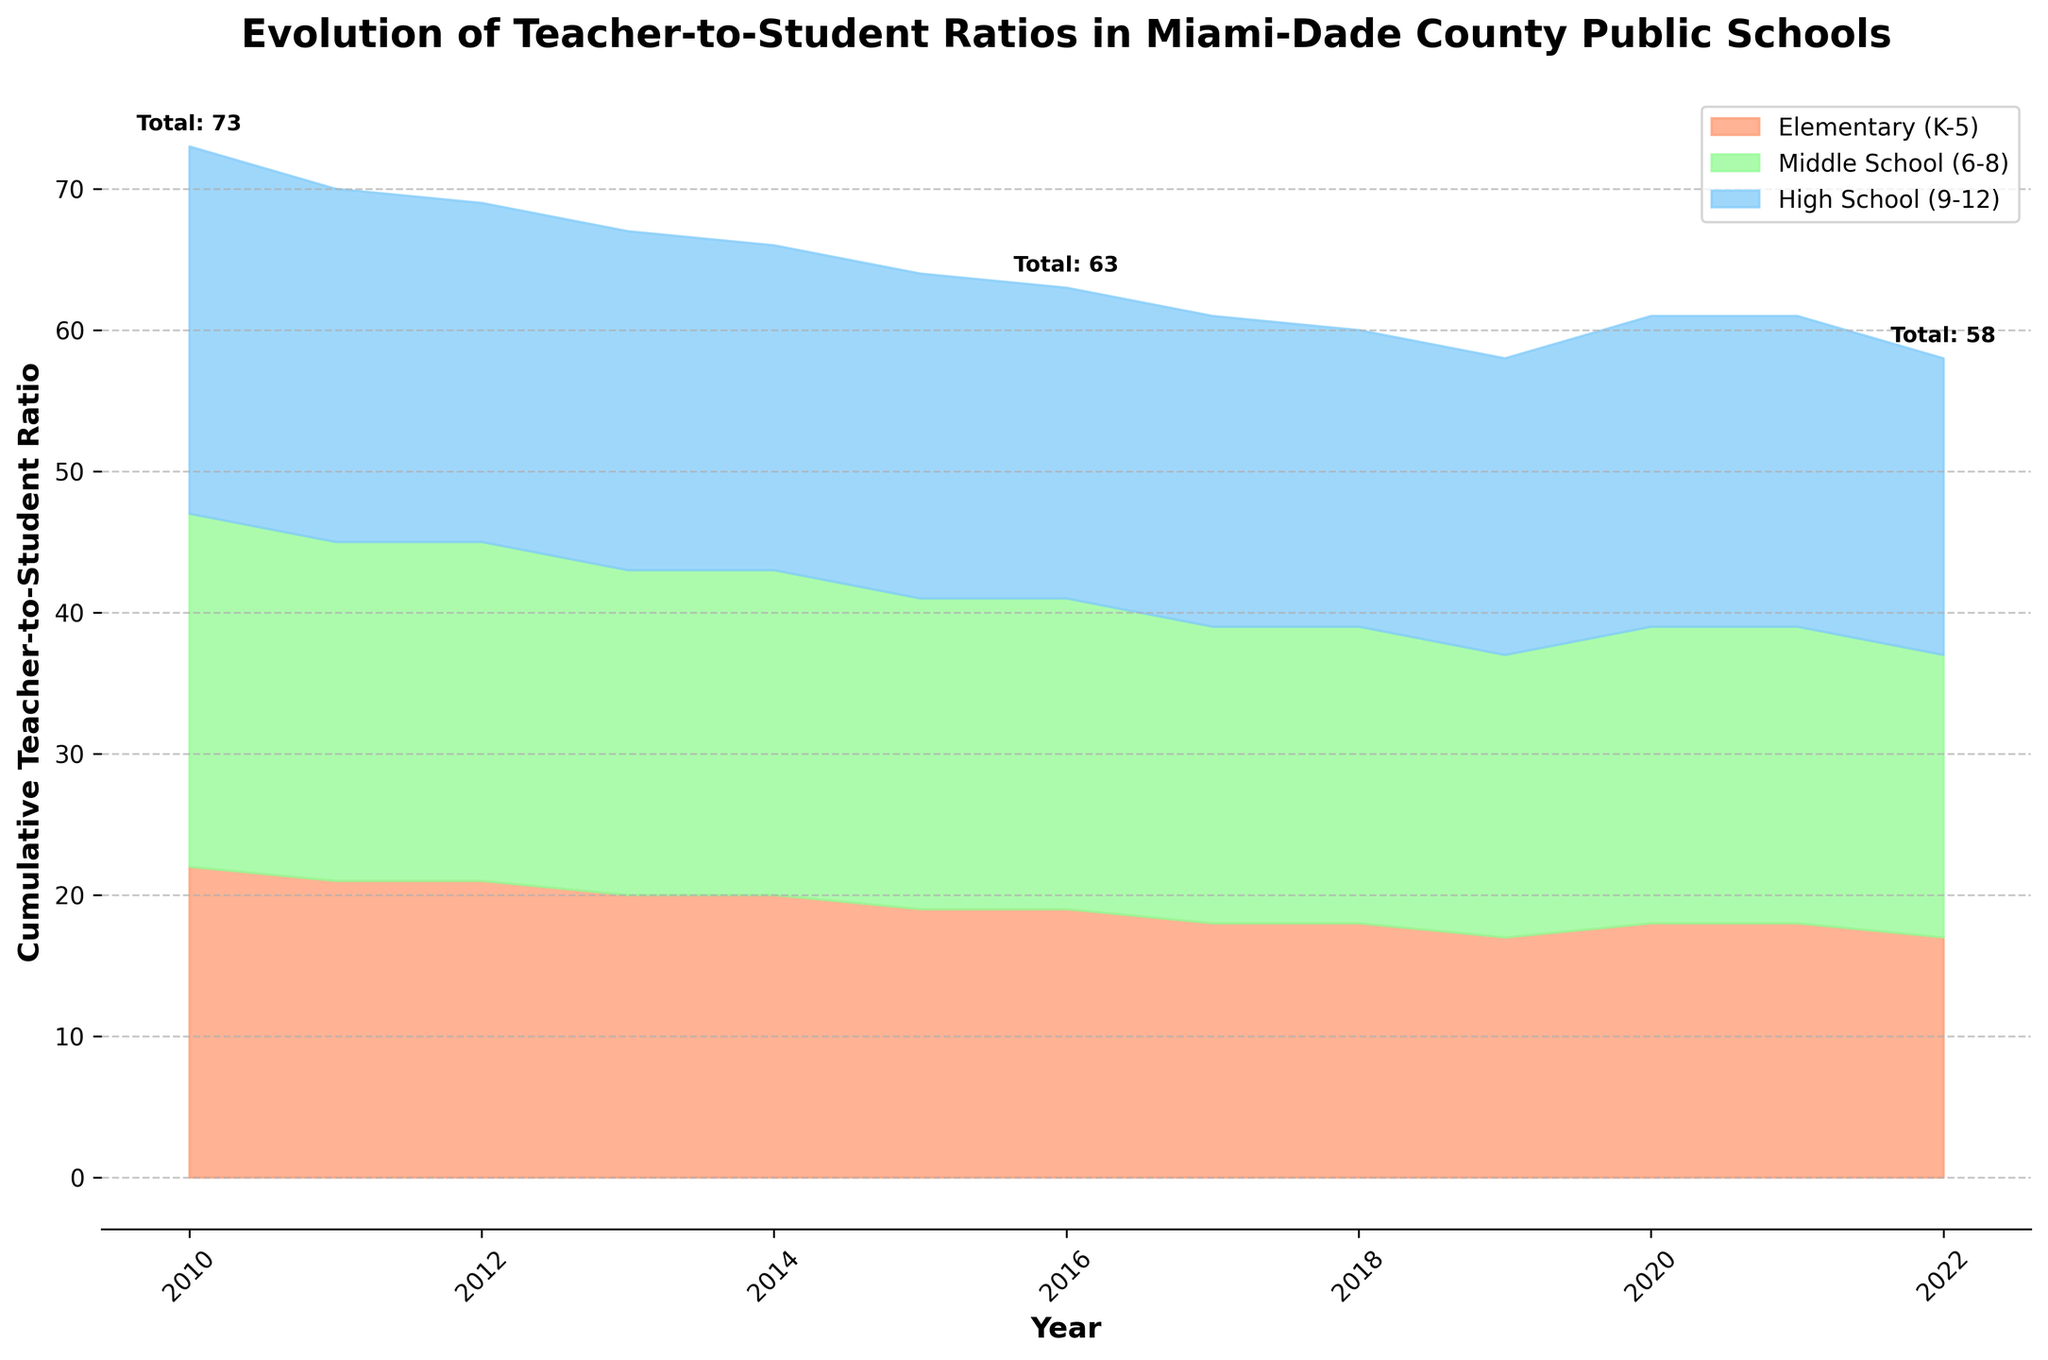What is the title of the figure? The title is usually displayed at the top of the figure. Here, it reads "Evolution of Teacher-to-Student Ratios in Miami-Dade County Public Schools."
Answer: Evolution of Teacher-to-Student Ratios in Miami-Dade County Public Schools In which year did the elementary (K-5) teacher-to-student ratio first reach 1:18? The stream graph shows the progression over time for different grade levels. By observing the area corresponding to elementary (K-5), it first reaches 1:18 in 2018.
Answer: 2018 What was the total cumulative teacher-to-student ratio for all grade levels in 2010? The graph annotates the total cumulative teacher-to-student ratio at specific years. For 2010, the annotation shows that it was 73.
Answer: 73 Which grade level had consistently the highest teacher-to-student ratio throughout most of the years? Observing the graph’s color-coded areas for each grade level, the high school (9-12) consistently occupies the largest vertical space, indicating the highest teacher-to-student ratio.
Answer: High School (9-12) How did the teacher-to-student ratio for middle school (6-8) change from 2015 to 2022? By comparing the height of the middle school area (green) at these two points, we see the ratio decreased from 1:22 in 2015 to 1:20 in 2022.
Answer: Decreased What were the teacher-to-student ratios for high school (9-12) in 2013 and 2019, and what is the difference between them? From the stream graph, the ratio for high school in 2013 is 1:24 and in 2019 is 1:21. The difference is 24 - 21 = 3.
Answer: 3 Which grade level saw the largest improvement (decrease) in teacher-to-student ratio between 2010 and 2022? By observing the overall visual reduction in each area, elementary (K-5) experienced the largest improvement, decreasing from 1:22 in 2010 to 1:17 in 2022.
Answer: Elementary (K-5) What was the trend for elementary (K-5) teacher-to-student ratios from 2016 to 2020? Checking the relevant portion of the graph, elementary (K-5) ratios remained constant at 1:19 from 2016 to 2017, then decreased to 1:18 in 2018, and remained constant until 2020.
Answer: Decrease and constant If the cumulative ratios at 2010, 2016, and 2022 were annotated as 73, 67, and 58 respectively, what is the overall change from 2010 to 2022? To find the overall change, subtract the cumulative ratio in 2022 from 2010: 73 - 58 = 15.
Answer: 15 